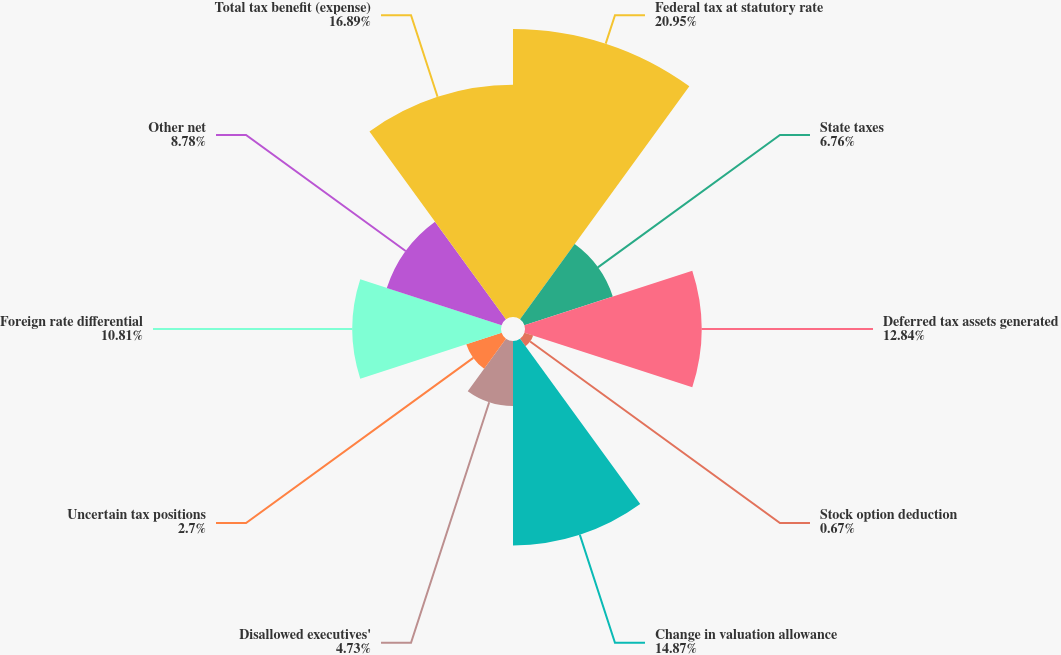Convert chart. <chart><loc_0><loc_0><loc_500><loc_500><pie_chart><fcel>Federal tax at statutory rate<fcel>State taxes<fcel>Deferred tax assets generated<fcel>Stock option deduction<fcel>Change in valuation allowance<fcel>Disallowed executives'<fcel>Uncertain tax positions<fcel>Foreign rate differential<fcel>Other net<fcel>Total tax benefit (expense)<nl><fcel>20.95%<fcel>6.76%<fcel>12.84%<fcel>0.67%<fcel>14.87%<fcel>4.73%<fcel>2.7%<fcel>10.81%<fcel>8.78%<fcel>16.89%<nl></chart> 